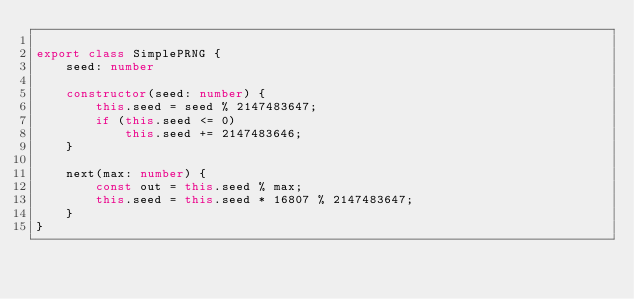<code> <loc_0><loc_0><loc_500><loc_500><_TypeScript_>
export class SimplePRNG {
    seed: number

    constructor(seed: number) {
        this.seed = seed % 2147483647;
        if (this.seed <= 0)
            this.seed += 2147483646;
    }

    next(max: number) {
        const out = this.seed % max;
        this.seed = this.seed * 16807 % 2147483647;
    }
}

</code> 